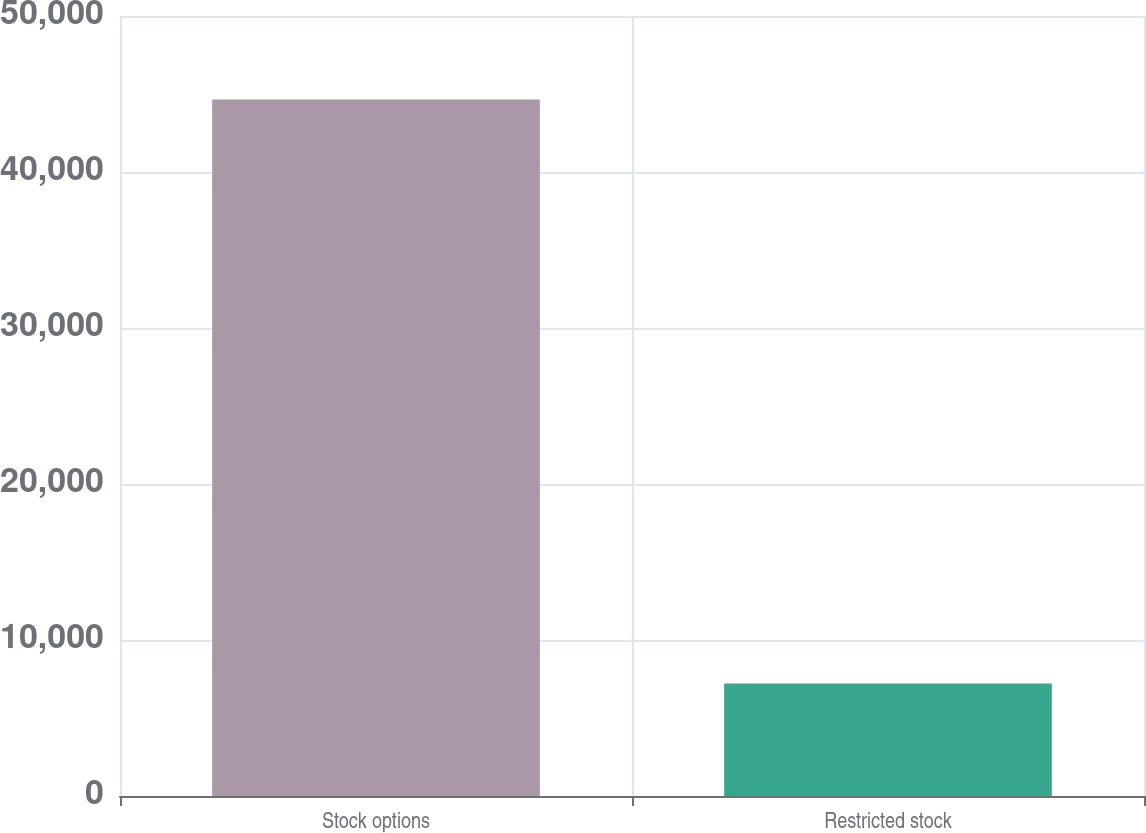Convert chart. <chart><loc_0><loc_0><loc_500><loc_500><bar_chart><fcel>Stock options<fcel>Restricted stock<nl><fcel>44643<fcel>7213<nl></chart> 